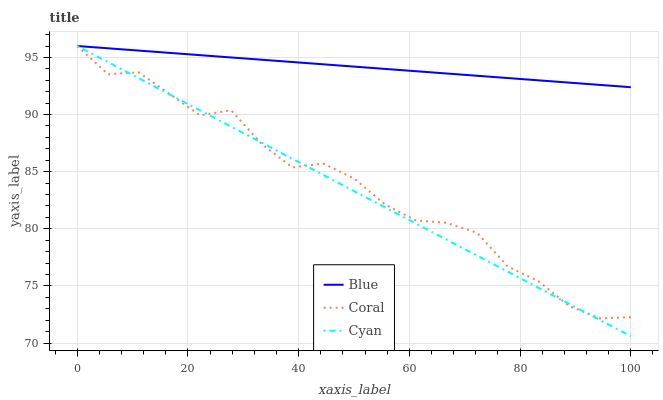Does Cyan have the minimum area under the curve?
Answer yes or no. Yes. Does Blue have the maximum area under the curve?
Answer yes or no. Yes. Does Coral have the minimum area under the curve?
Answer yes or no. No. Does Coral have the maximum area under the curve?
Answer yes or no. No. Is Blue the smoothest?
Answer yes or no. Yes. Is Coral the roughest?
Answer yes or no. Yes. Is Cyan the smoothest?
Answer yes or no. No. Is Cyan the roughest?
Answer yes or no. No. Does Cyan have the lowest value?
Answer yes or no. Yes. Does Coral have the lowest value?
Answer yes or no. No. Does Coral have the highest value?
Answer yes or no. Yes. Does Cyan intersect Coral?
Answer yes or no. Yes. Is Cyan less than Coral?
Answer yes or no. No. Is Cyan greater than Coral?
Answer yes or no. No. 